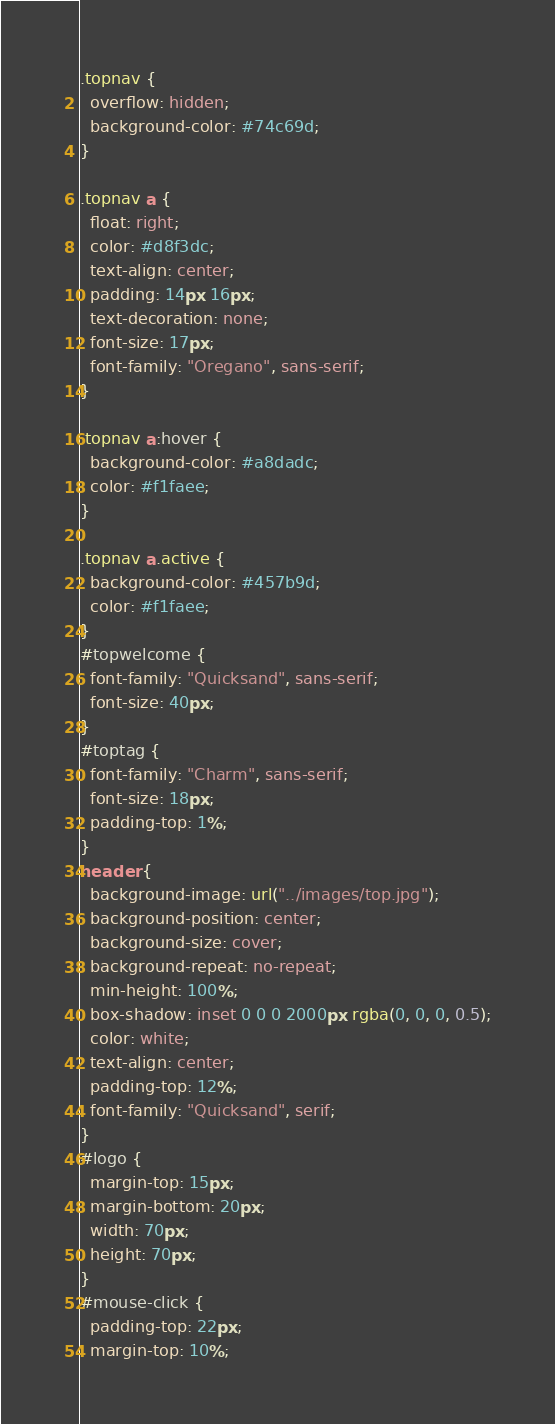<code> <loc_0><loc_0><loc_500><loc_500><_CSS_>.topnav {
  overflow: hidden;
  background-color: #74c69d;
}

.topnav a {
  float: right;
  color: #d8f3dc;
  text-align: center;
  padding: 14px 16px;
  text-decoration: none;
  font-size: 17px;
  font-family: "Oregano", sans-serif;
}

.topnav a:hover {
  background-color: #a8dadc;
  color: #f1faee;
}

.topnav a.active {
  background-color: #457b9d;
  color: #f1faee;
}
#topwelcome {
  font-family: "Quicksand", sans-serif;
  font-size: 40px;
}
#toptag {
  font-family: "Charm", sans-serif;
  font-size: 18px;
  padding-top: 1%;
}
header {
  background-image: url("../images/top.jpg");
  background-position: center;
  background-size: cover;
  background-repeat: no-repeat;
  min-height: 100%;
  box-shadow: inset 0 0 0 2000px rgba(0, 0, 0, 0.5);
  color: white;
  text-align: center;
  padding-top: 12%;
  font-family: "Quicksand", serif;
}
#logo {
  margin-top: 15px;
  margin-bottom: 20px;
  width: 70px;
  height: 70px;
}
#mouse-click {
  padding-top: 22px;
  margin-top: 10%;</code> 